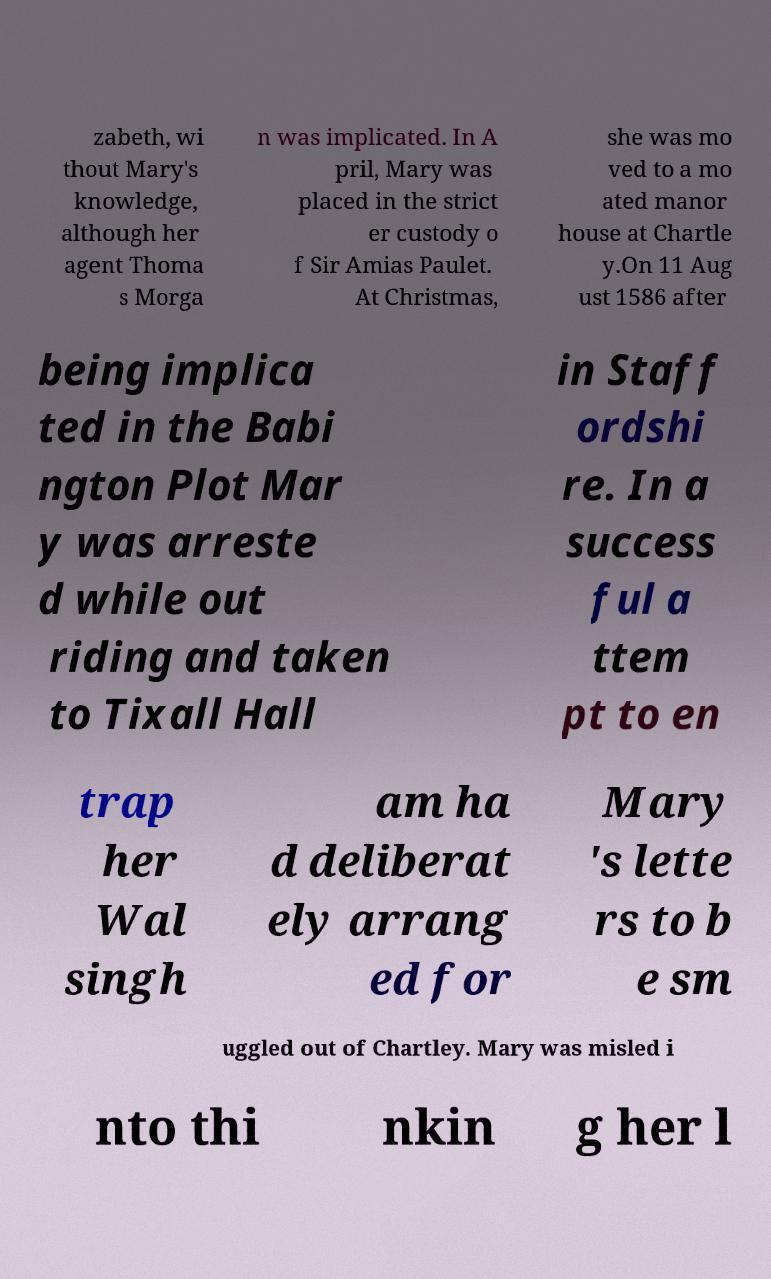There's text embedded in this image that I need extracted. Can you transcribe it verbatim? zabeth, wi thout Mary's knowledge, although her agent Thoma s Morga n was implicated. In A pril, Mary was placed in the strict er custody o f Sir Amias Paulet. At Christmas, she was mo ved to a mo ated manor house at Chartle y.On 11 Aug ust 1586 after being implica ted in the Babi ngton Plot Mar y was arreste d while out riding and taken to Tixall Hall in Staff ordshi re. In a success ful a ttem pt to en trap her Wal singh am ha d deliberat ely arrang ed for Mary 's lette rs to b e sm uggled out of Chartley. Mary was misled i nto thi nkin g her l 